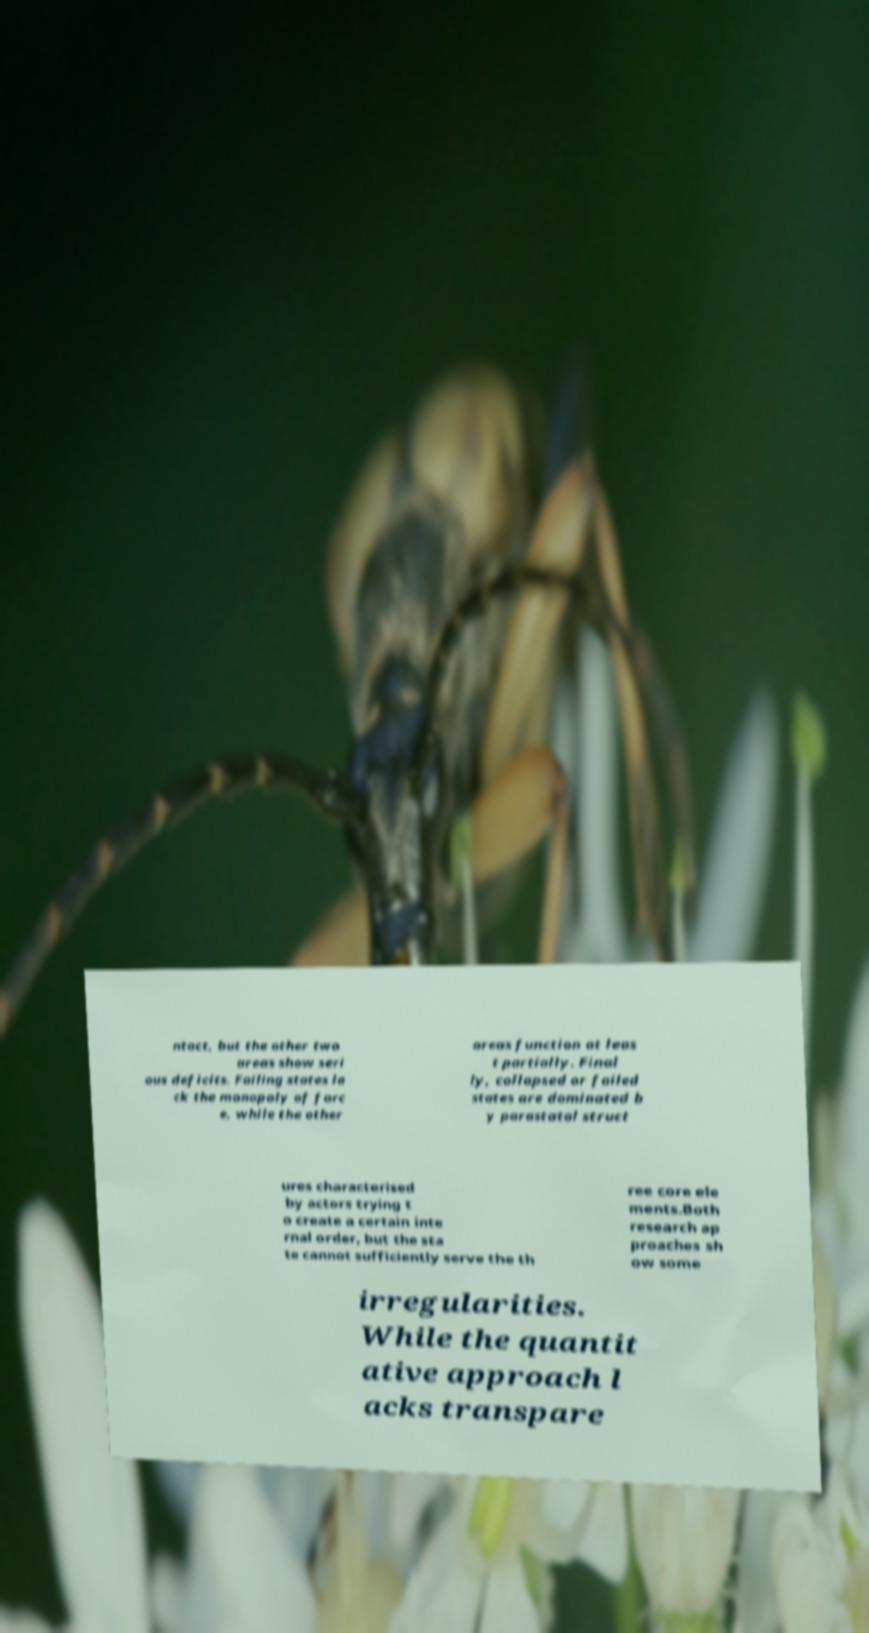For documentation purposes, I need the text within this image transcribed. Could you provide that? ntact, but the other two areas show seri ous deficits. Failing states la ck the monopoly of forc e, while the other areas function at leas t partially. Final ly, collapsed or failed states are dominated b y parastatal struct ures characterised by actors trying t o create a certain inte rnal order, but the sta te cannot sufficiently serve the th ree core ele ments.Both research ap proaches sh ow some irregularities. While the quantit ative approach l acks transpare 